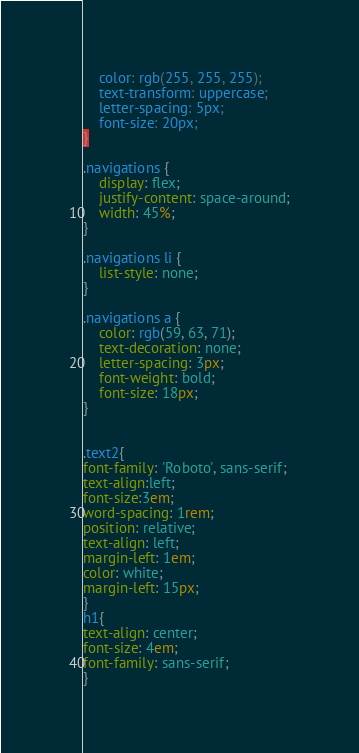Convert code to text. <code><loc_0><loc_0><loc_500><loc_500><_CSS_>    color: rgb(255, 255, 255);
    text-transform: uppercase;
    letter-spacing: 5px;
    font-size: 20px;
}

.navigations {
    display: flex;
    justify-content: space-around;
    width: 45%;
}

.navigations li {
    list-style: none;
}

.navigations a {
    color: rgb(59, 63, 71);
    text-decoration: none;
    letter-spacing: 3px;
    font-weight: bold;
    font-size: 18px;
}


.text2{
font-family: 'Roboto', sans-serif;
text-align:left;
font-size:3em;
word-spacing: 1rem;
position: relative;
text-align: left;
margin-left: 1em;
color: white;
margin-left: 15px;
}
h1{
text-align: center;
font-size: 4em;
font-family: sans-serif;
}</code> 